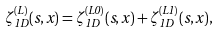Convert formula to latex. <formula><loc_0><loc_0><loc_500><loc_500>\zeta _ { 1 D } ^ { ( L ) } ( s , x ) = \zeta _ { 1 D } ^ { ( L 0 ) } ( s , x ) + \zeta _ { 1 D } ^ { ( L 1 ) } ( s , x ) ,</formula> 